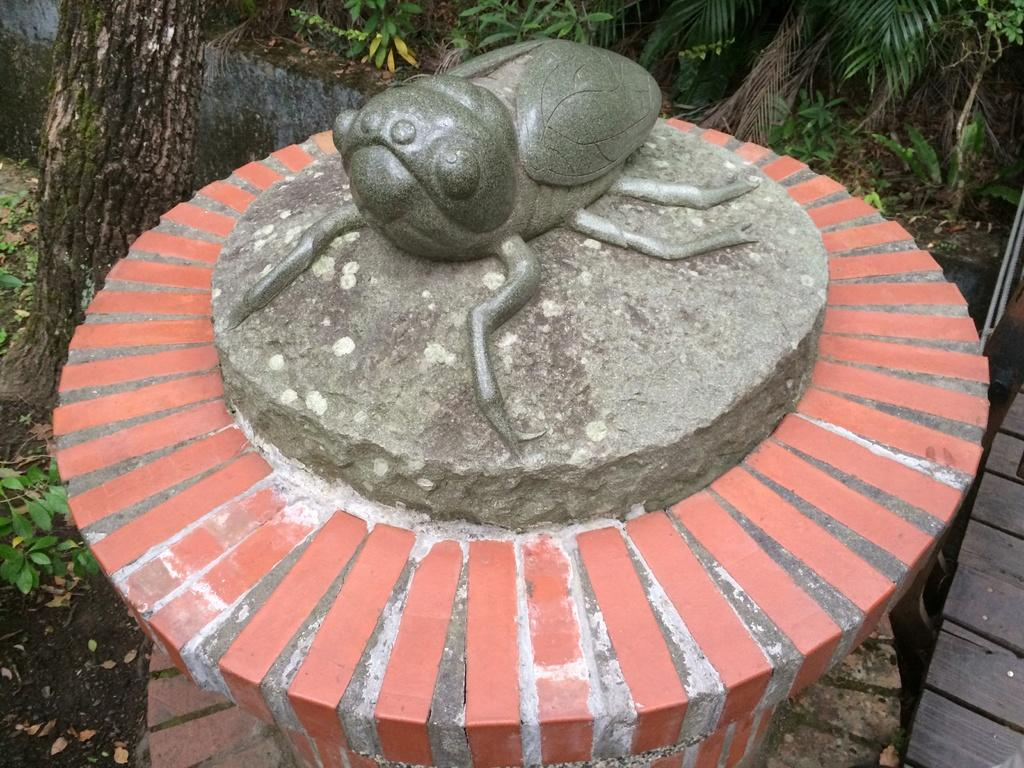What is the main subject in the image? There is a statue in the image. What can be seen in the background of the image? There are plants and trees in the background of the image. What is the color of the plants and trees in the image? The plants and trees are in green color. Can you see any fire or flames near the statue in the image? No, there is no fire or flames visible near the statue in the image. Are there any visible hands on the statue in the image? The image does not show any visible hands on the statue. 